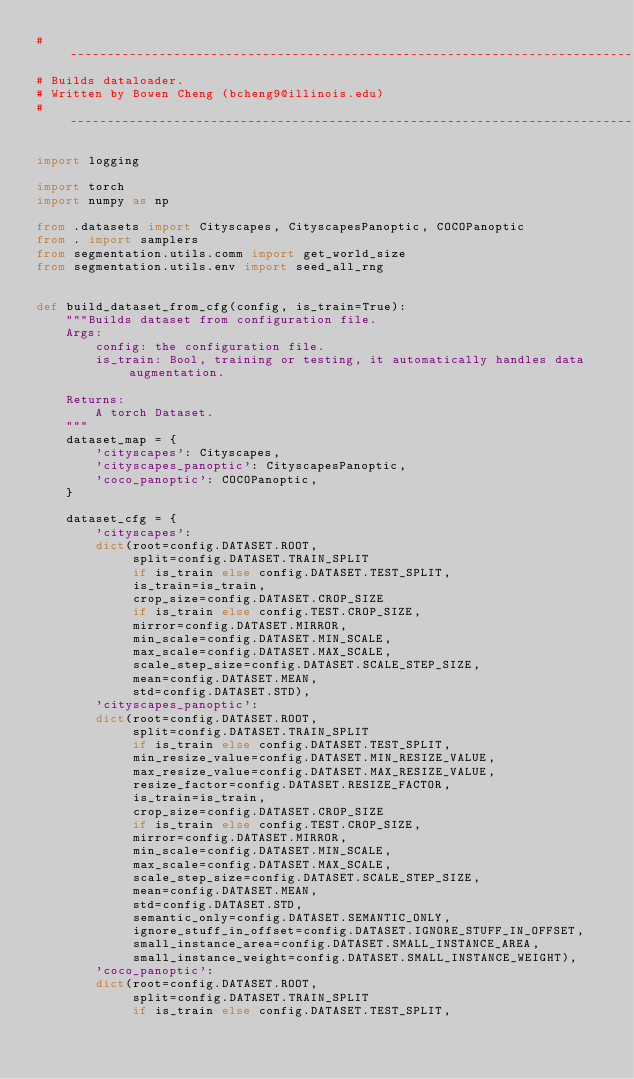Convert code to text. <code><loc_0><loc_0><loc_500><loc_500><_Python_># ------------------------------------------------------------------------------
# Builds dataloader.
# Written by Bowen Cheng (bcheng9@illinois.edu)
# ------------------------------------------------------------------------------

import logging

import torch
import numpy as np

from .datasets import Cityscapes, CityscapesPanoptic, COCOPanoptic
from . import samplers
from segmentation.utils.comm import get_world_size
from segmentation.utils.env import seed_all_rng


def build_dataset_from_cfg(config, is_train=True):
    """Builds dataset from configuration file.
    Args:
        config: the configuration file.
        is_train: Bool, training or testing, it automatically handles data augmentation.

    Returns:
        A torch Dataset.
    """
    dataset_map = {
        'cityscapes': Cityscapes,
        'cityscapes_panoptic': CityscapesPanoptic,
        'coco_panoptic': COCOPanoptic,
    }

    dataset_cfg = {
        'cityscapes':
        dict(root=config.DATASET.ROOT,
             split=config.DATASET.TRAIN_SPLIT
             if is_train else config.DATASET.TEST_SPLIT,
             is_train=is_train,
             crop_size=config.DATASET.CROP_SIZE
             if is_train else config.TEST.CROP_SIZE,
             mirror=config.DATASET.MIRROR,
             min_scale=config.DATASET.MIN_SCALE,
             max_scale=config.DATASET.MAX_SCALE,
             scale_step_size=config.DATASET.SCALE_STEP_SIZE,
             mean=config.DATASET.MEAN,
             std=config.DATASET.STD),
        'cityscapes_panoptic':
        dict(root=config.DATASET.ROOT,
             split=config.DATASET.TRAIN_SPLIT
             if is_train else config.DATASET.TEST_SPLIT,
             min_resize_value=config.DATASET.MIN_RESIZE_VALUE,
             max_resize_value=config.DATASET.MAX_RESIZE_VALUE,
             resize_factor=config.DATASET.RESIZE_FACTOR,
             is_train=is_train,
             crop_size=config.DATASET.CROP_SIZE
             if is_train else config.TEST.CROP_SIZE,
             mirror=config.DATASET.MIRROR,
             min_scale=config.DATASET.MIN_SCALE,
             max_scale=config.DATASET.MAX_SCALE,
             scale_step_size=config.DATASET.SCALE_STEP_SIZE,
             mean=config.DATASET.MEAN,
             std=config.DATASET.STD,
             semantic_only=config.DATASET.SEMANTIC_ONLY,
             ignore_stuff_in_offset=config.DATASET.IGNORE_STUFF_IN_OFFSET,
             small_instance_area=config.DATASET.SMALL_INSTANCE_AREA,
             small_instance_weight=config.DATASET.SMALL_INSTANCE_WEIGHT),
        'coco_panoptic':
        dict(root=config.DATASET.ROOT,
             split=config.DATASET.TRAIN_SPLIT
             if is_train else config.DATASET.TEST_SPLIT,</code> 